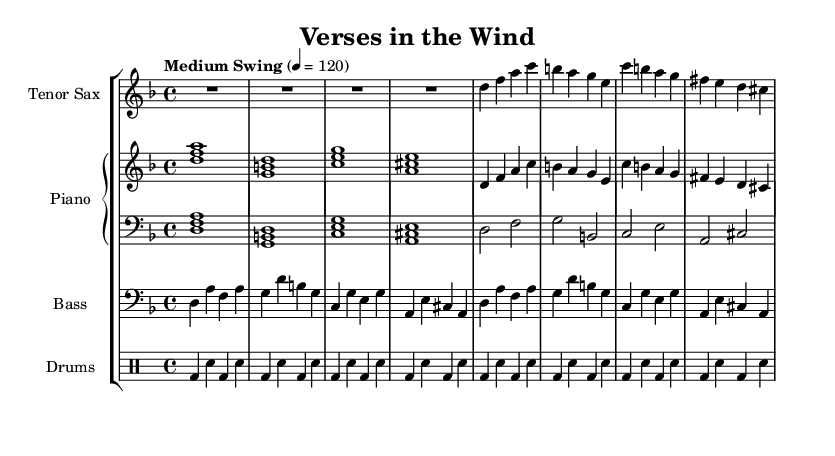What is the key signature of this music? The key signature indicated by the `\key` command in the code is D minor, which has one flat (B flat).
Answer: D minor What is the time signature of this piece? The time signature specified in the code is 4/4, meaning there are four beats in each measure and the quarter note receives one beat.
Answer: 4/4 What is the tempo marking for this piece? The tempo marking given in the code is "Medium Swing" at a dotted quarter note equals 120, which indicates a swing style rhythm.
Answer: Medium Swing How many measures does the saxophone part contain? The saxophone part has eight measures as indicated by the rhythmic notation; each set of notes and rests corresponds to one measure.
Answer: 8 What instrument plays the bass line? The instrument labeled with the `\new Staff \with { instrumentName = "Bass" }` indicates that the bass part is played by the bass instrument.
Answer: Bass What rhythmic figure is used for the drum part? The drum part consists of a repeated figure of bass drum and snare drum, demonstrating a typical jazz rhythm pattern throughout the piece.
Answer: Bass and snare What type of harmony is primarily used in the piano right hand? The right hand of the piano uses harmonies built on triads, which is typical for jazz, emphasizing root, third, and fifth.
Answer: Triads 